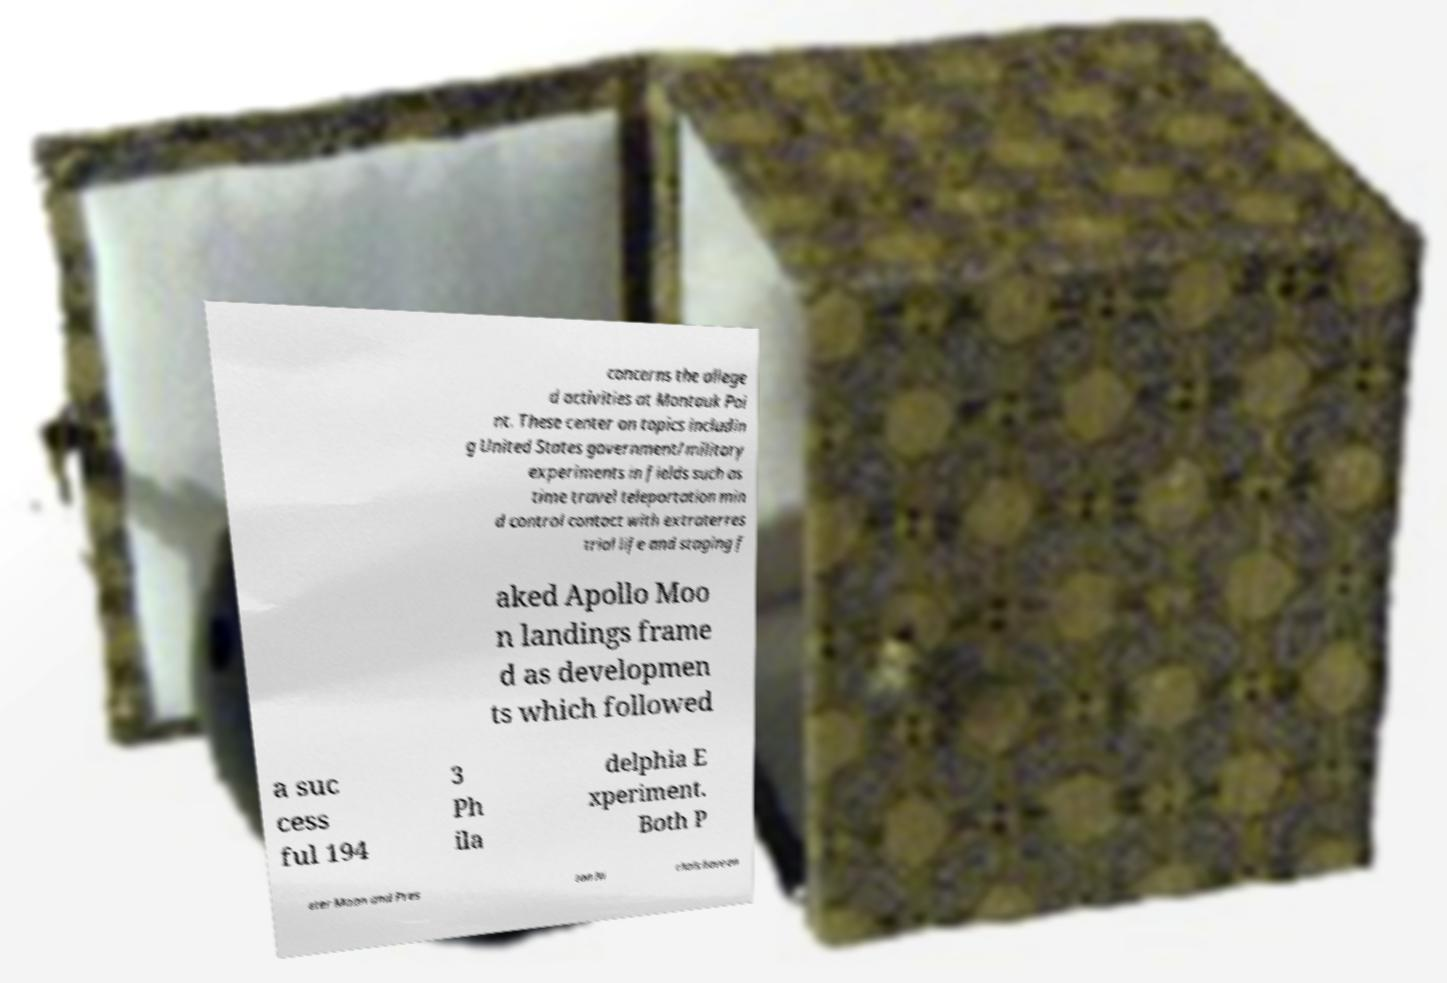What messages or text are displayed in this image? I need them in a readable, typed format. concerns the allege d activities at Montauk Poi nt. These center on topics includin g United States government/military experiments in fields such as time travel teleportation min d control contact with extraterres trial life and staging f aked Apollo Moo n landings frame d as developmen ts which followed a suc cess ful 194 3 Ph ila delphia E xperiment. Both P eter Moon and Pres ton Ni chols have en 